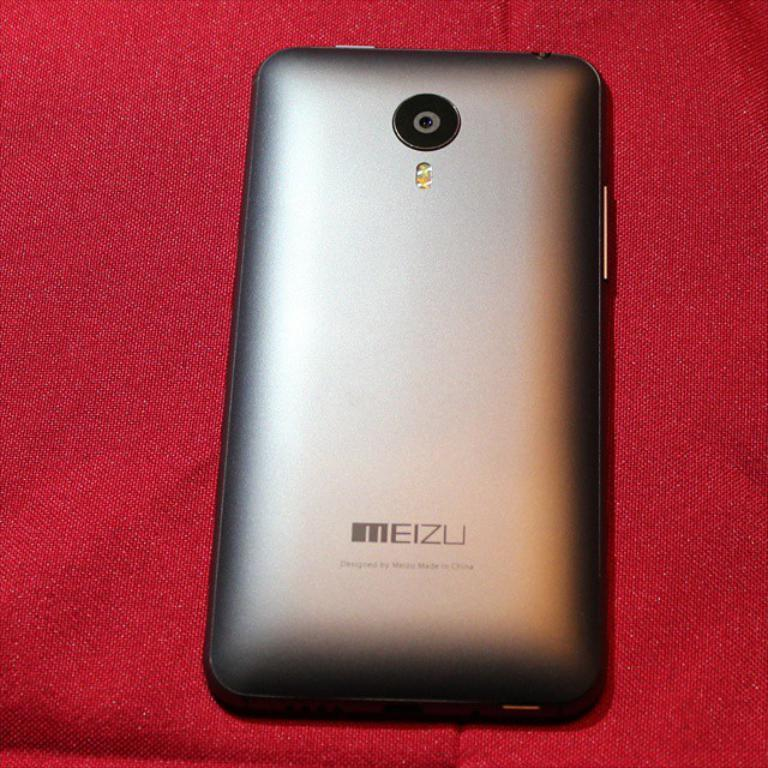<image>
Create a compact narrative representing the image presented. the Meizu phone is laying on a red tablecloth 